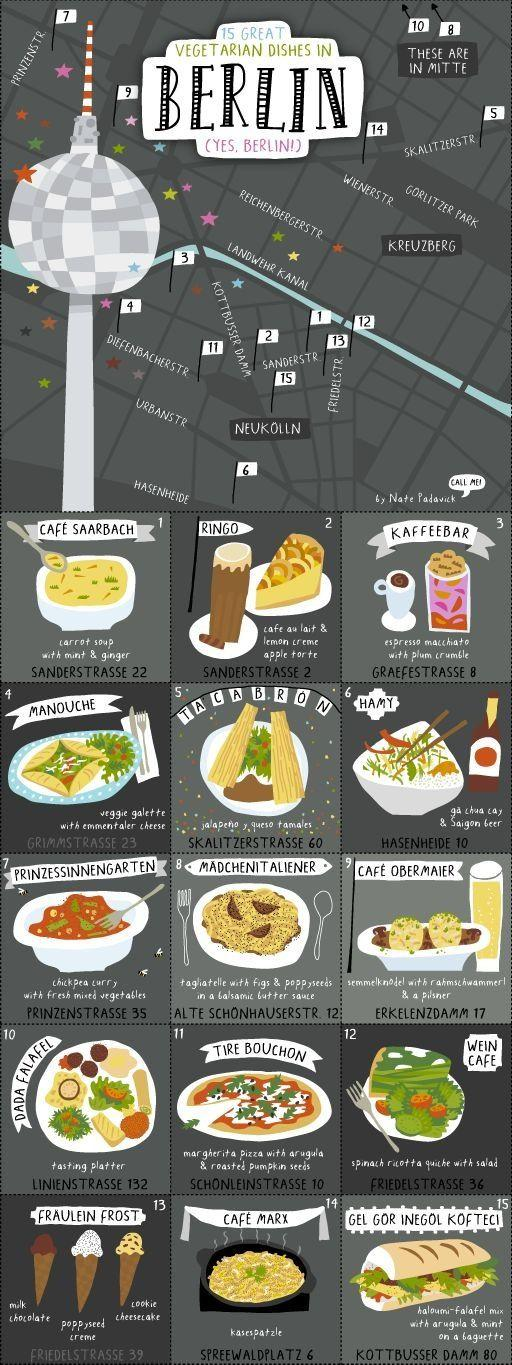Outline some significant characteristics in this image. Friedelstrasse is home to several eateries that offer vegetarian dishes, including the Wein Cafe and Fraulein Frost. In Hasenheide, there are several eateries that offer vegetarian dishes, including Hamy. Cafe Saarbach is located at Sanderstrasse 22. Wein Cafe, located at Friedelstrasse 36, serves a vegetarian dish of spinach ricotta quiche with a salad as a side. Prinzenstrasse is home to several eateries that serve vegetarian dishes, including Prinzessinnengarten, which is a popular destination for those seeking vegetarian cuisine. 